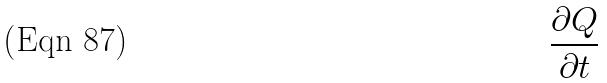<formula> <loc_0><loc_0><loc_500><loc_500>\frac { \partial Q } { \partial t }</formula> 